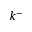Convert formula to latex. <formula><loc_0><loc_0><loc_500><loc_500>k ^ { - }</formula> 